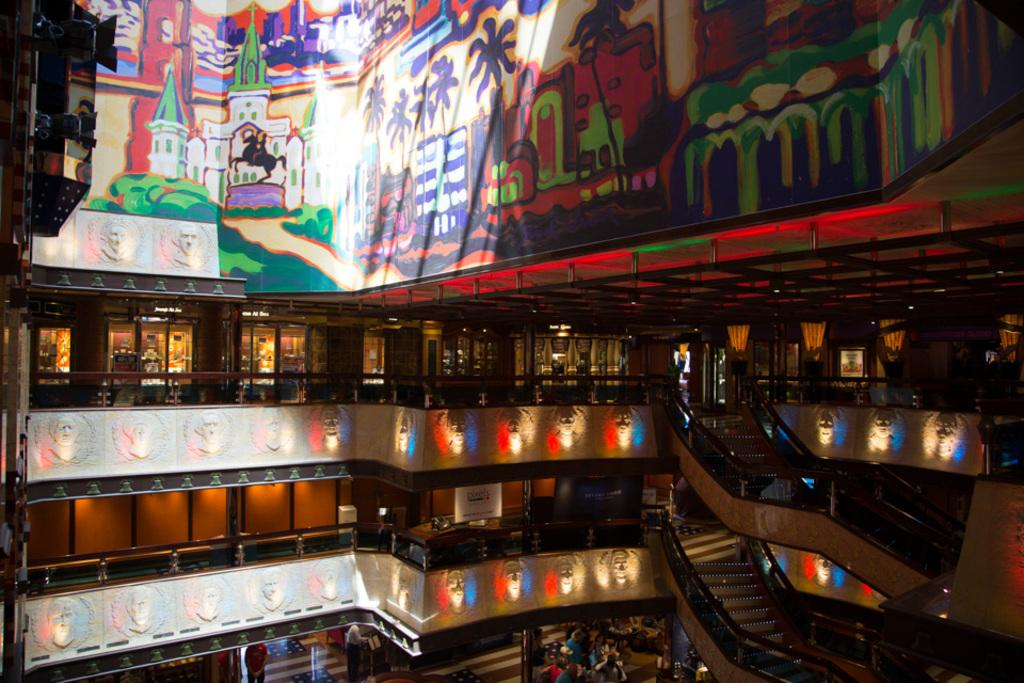What type of structure is visible in the image? There is a building in the image. What animal can be seen in the image? There is a horse in the image. Are there any architectural features in the image? Yes, there are stairs in the image. What type of vegetation is present in the image? There are plants in the image. Where is the crate located in the image? There is no crate present in the image. Can you see a chessboard or chess pieces in the image? There is no chessboard or chess pieces present in the image. 